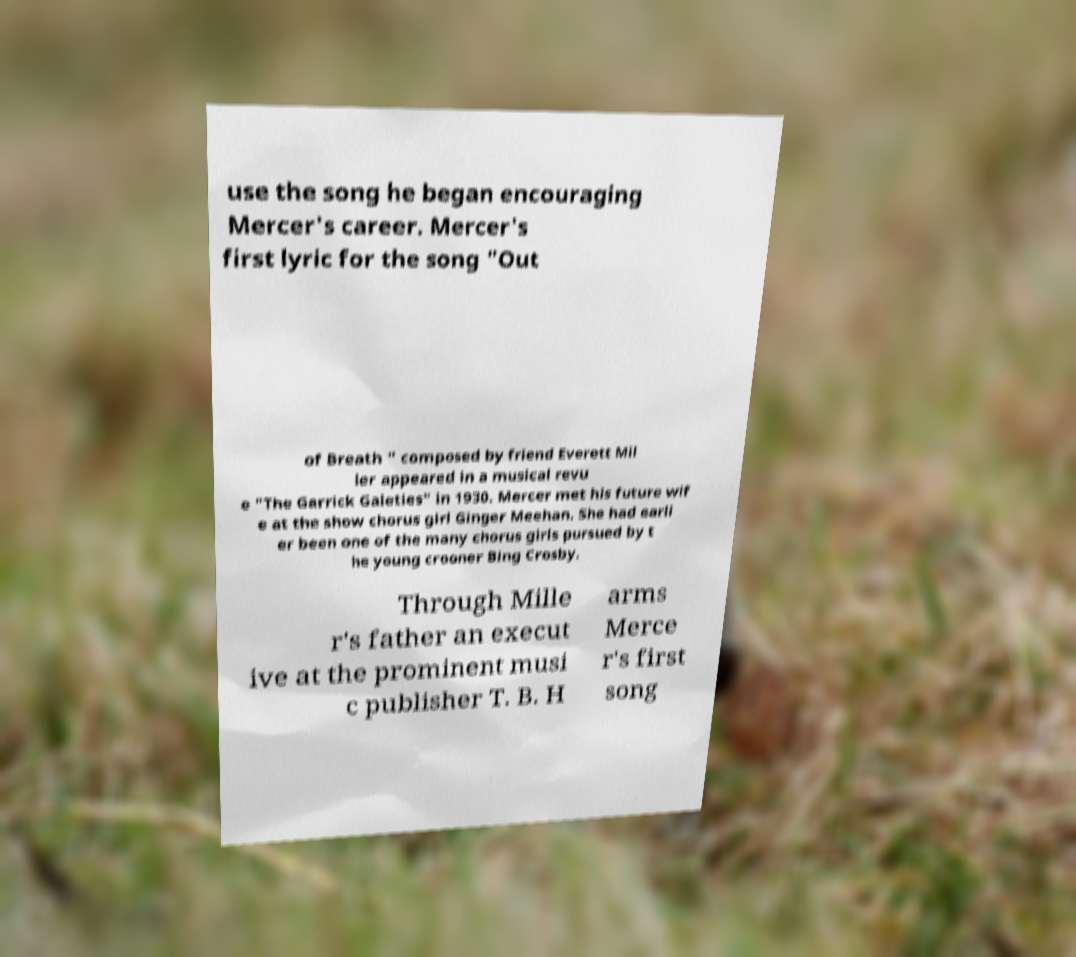What messages or text are displayed in this image? I need them in a readable, typed format. use the song he began encouraging Mercer's career. Mercer's first lyric for the song "Out of Breath " composed by friend Everett Mil ler appeared in a musical revu e "The Garrick Gaieties" in 1930. Mercer met his future wif e at the show chorus girl Ginger Meehan. She had earli er been one of the many chorus girls pursued by t he young crooner Bing Crosby. Through Mille r's father an execut ive at the prominent musi c publisher T. B. H arms Merce r's first song 